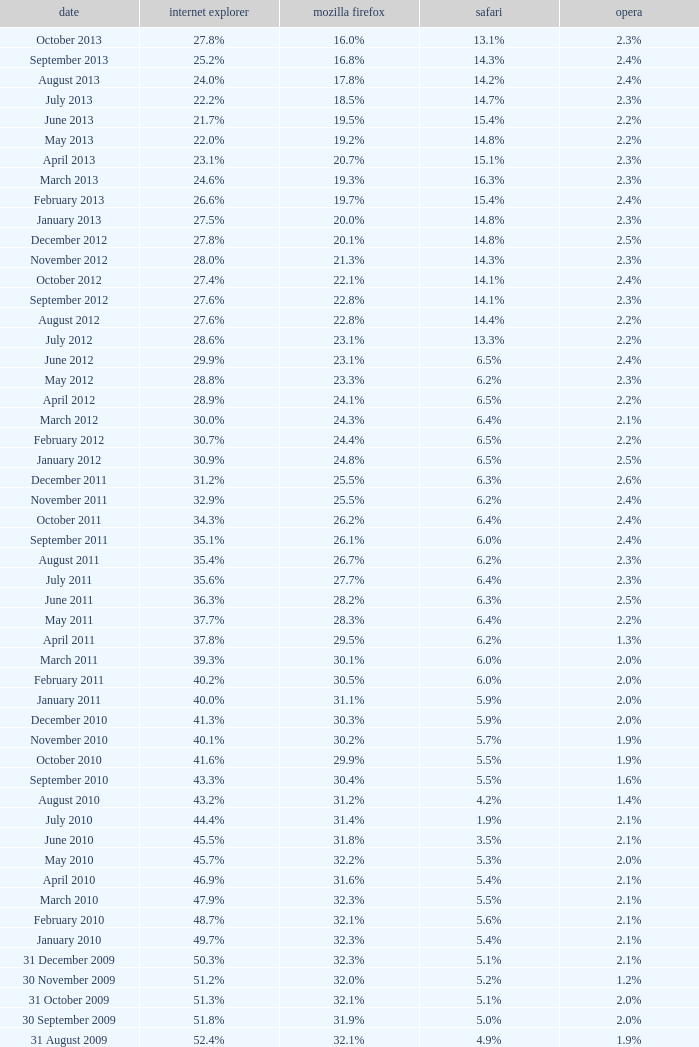What is the safari value with a 28.0% internet explorer? 14.3%. 